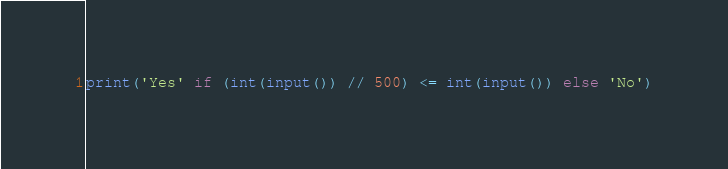Convert code to text. <code><loc_0><loc_0><loc_500><loc_500><_Python_>print('Yes' if (int(input()) // 500) <= int(input()) else 'No')</code> 